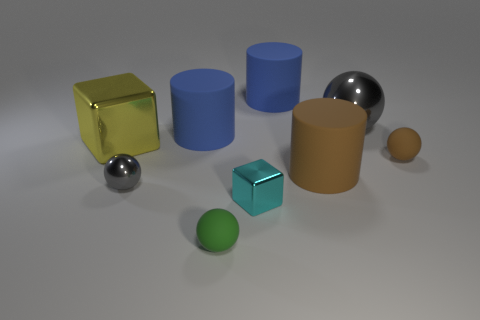Is the number of small brown matte things to the left of the big sphere greater than the number of tiny rubber objects behind the brown cylinder?
Your response must be concise. No. The yellow shiny block is what size?
Give a very brief answer. Large. What shape is the big yellow object that is made of the same material as the tiny cyan object?
Your answer should be compact. Cube. Do the gray metal object right of the tiny cube and the green rubber object have the same shape?
Your answer should be compact. Yes. What number of objects are either tiny purple matte things or small cyan objects?
Make the answer very short. 1. What is the sphere that is both in front of the small brown thing and behind the tiny cyan metal cube made of?
Your answer should be compact. Metal. Do the brown rubber cylinder and the green thing have the same size?
Keep it short and to the point. No. What size is the metal thing in front of the gray metallic object that is in front of the big gray sphere?
Provide a short and direct response. Small. What number of matte objects are both to the right of the small cyan metallic block and in front of the small brown sphere?
Offer a very short reply. 1. There is a big cylinder that is on the left side of the tiny shiny thing that is in front of the small gray sphere; is there a large cylinder behind it?
Offer a very short reply. Yes. 